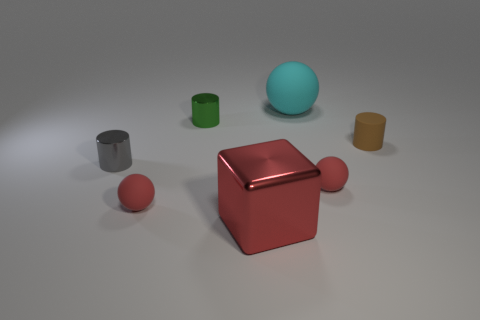Add 2 cubes. How many objects exist? 9 Subtract all blocks. How many objects are left? 6 Subtract 1 red cubes. How many objects are left? 6 Subtract all blocks. Subtract all green things. How many objects are left? 5 Add 3 tiny red rubber things. How many tiny red rubber things are left? 5 Add 3 green cylinders. How many green cylinders exist? 4 